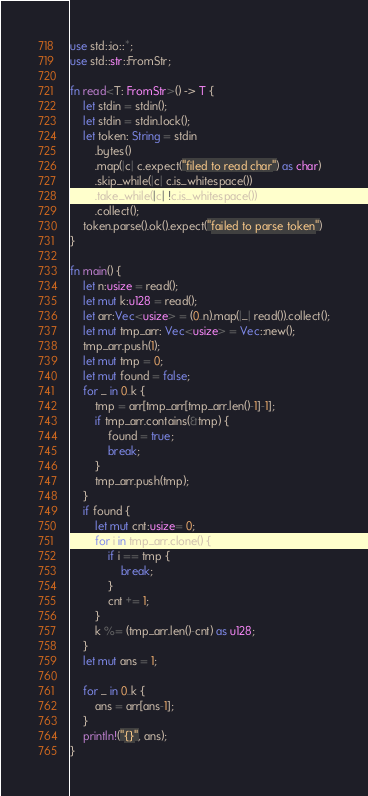Convert code to text. <code><loc_0><loc_0><loc_500><loc_500><_Rust_>use std::io::*;
use std::str::FromStr;

fn read<T: FromStr>() -> T {
    let stdin = stdin();
    let stdin = stdin.lock();
    let token: String = stdin
        .bytes()
        .map(|c| c.expect("filed to read char") as char)
        .skip_while(|c| c.is_whitespace())
        .take_while(|c| !c.is_whitespace())
        .collect();
    token.parse().ok().expect("failed to parse token")
}

fn main() {
    let n:usize = read();
    let mut k:u128 = read();
    let arr:Vec<usize> = (0..n).map(|_| read()).collect();
    let mut tmp_arr: Vec<usize> = Vec::new();
    tmp_arr.push(1);
    let mut tmp = 0;
    let mut found = false;
    for _ in 0..k {
        tmp = arr[tmp_arr[tmp_arr.len()-1]-1];
        if tmp_arr.contains(&tmp) {
            found = true;
            break;
        }
        tmp_arr.push(tmp);
    }
    if found {
        let mut cnt:usize= 0;
        for i in tmp_arr.clone() {
            if i == tmp {
                break;
            }
            cnt += 1;
        }
        k %= (tmp_arr.len()-cnt) as u128;
    }
    let mut ans = 1;

    for _ in 0..k {
        ans = arr[ans-1];
    }
    println!("{}", ans);
}
</code> 